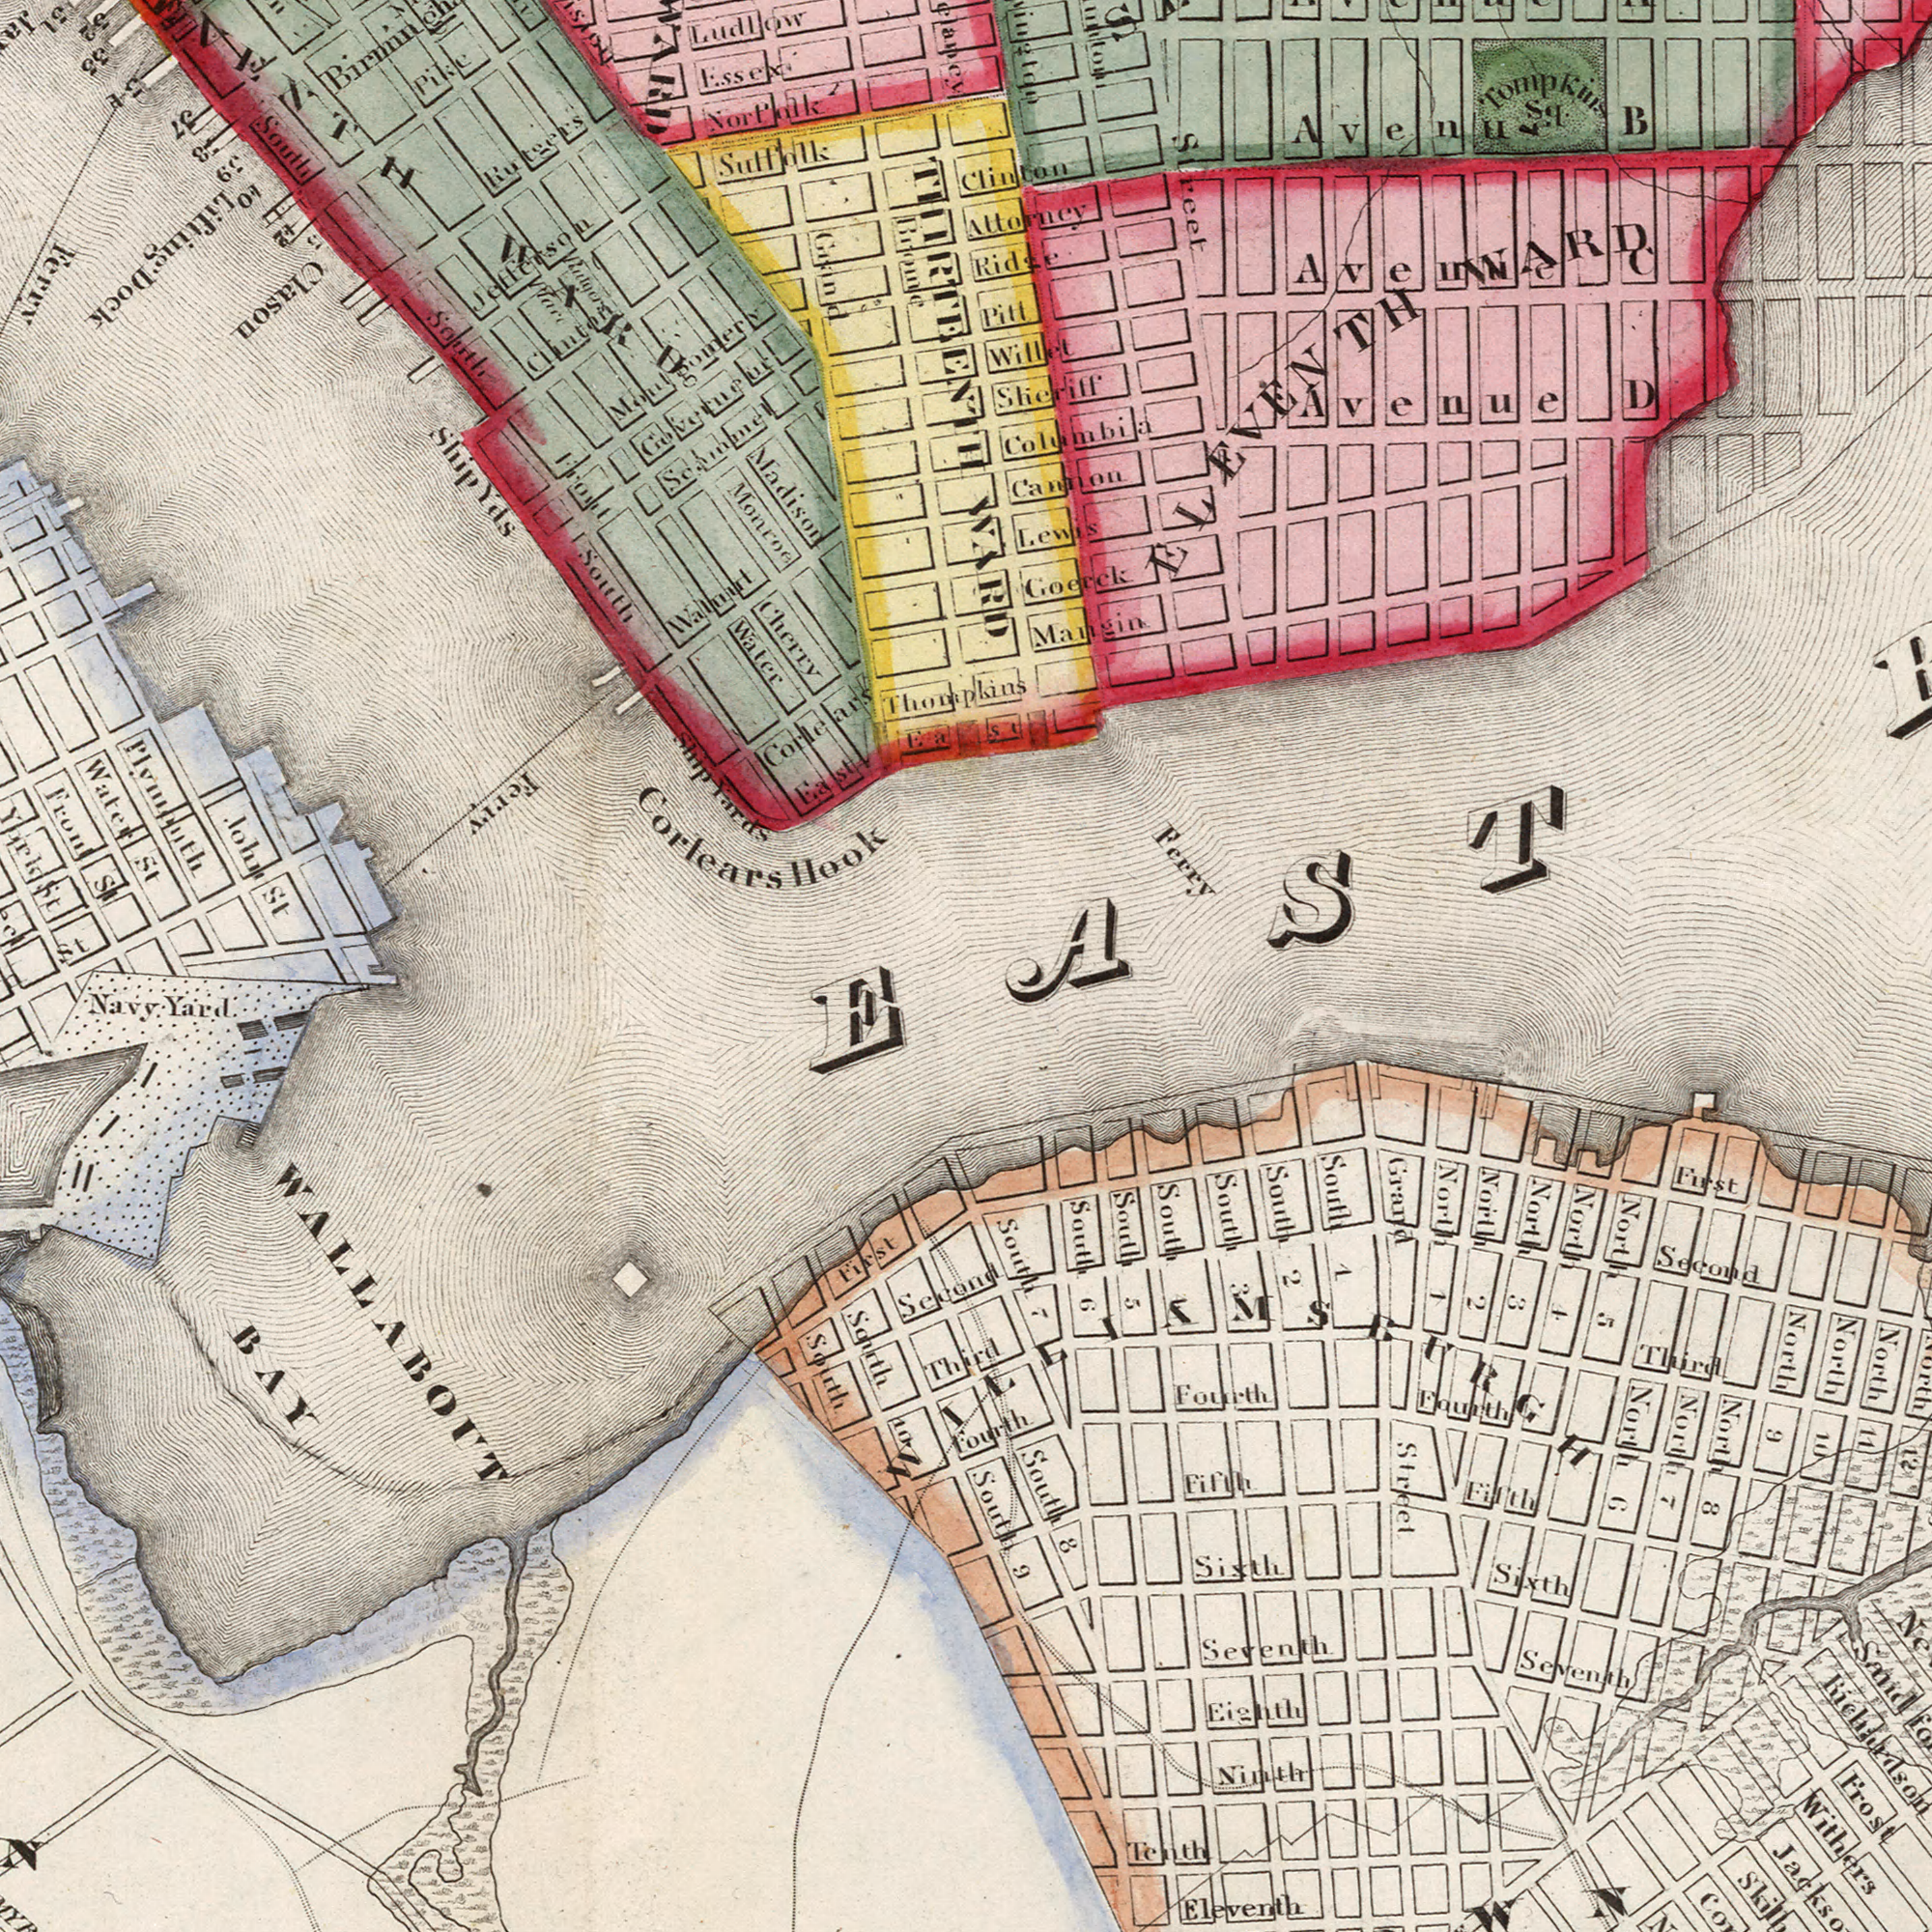What text can you see in the top-right section? Ferry Cannon Tompkius Sq. Sheriff Columbia Goerck Attorney Avenue B Mangin Pitt Ridge Willet Avenue D Street Lewis WARD Clinton Avenue C ELEVENTH WARD EAST What text is shown in the bottom-left quadrant? WALLABOUT BAY First Navy Yard South South 10 Third Second What text is shown in the top-left quadrant? Plymouth Cherry Corlears Hook ship Yards Water St Essexi John St Thompkins Sulfhlk Corlears Walnurt Scammel South Norfolk Montgomery WARD East Madison Ludlow South Monroe Grand St. East Rutgers Jefferson South Hare York St. ShipYds Front St Pike Governeur Clinton Water Front 31 32 33 37 38 39 Lifting Dock Ferry Clason Brome THIRTEENTH Ferry 34 Hare What text is visible in the lower-right corner? Withers Frost Eleventh Grand Second Seventh First South 9 South 4 South 3 Richardson Sixth Seventh South 2 Ninth North 10 North 9 Sixth Fourth South 1 Fifth Tenth North 1 Fourth North 5 North 11 North 2 Street Sand North 8 South 5 Fourth Fifth Third Eighth North 6 South 7 North 4 South 6 South 8 WIEEIKMSBURGH North 3 North 12 North 7 